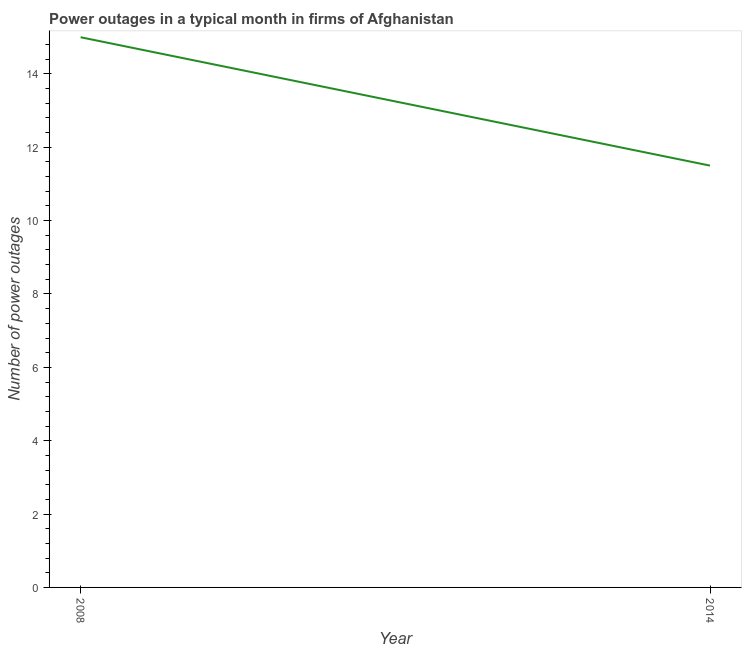What is the number of power outages in 2008?
Ensure brevity in your answer.  15. Across all years, what is the minimum number of power outages?
Give a very brief answer. 11.5. In which year was the number of power outages maximum?
Your answer should be very brief. 2008. In which year was the number of power outages minimum?
Provide a short and direct response. 2014. What is the average number of power outages per year?
Provide a succinct answer. 13.25. What is the median number of power outages?
Ensure brevity in your answer.  13.25. In how many years, is the number of power outages greater than 4.8 ?
Provide a succinct answer. 2. Do a majority of the years between 2014 and 2008 (inclusive) have number of power outages greater than 1.6 ?
Your response must be concise. No. What is the ratio of the number of power outages in 2008 to that in 2014?
Offer a very short reply. 1.3. In how many years, is the number of power outages greater than the average number of power outages taken over all years?
Your answer should be very brief. 1. How many lines are there?
Your answer should be very brief. 1. What is the difference between two consecutive major ticks on the Y-axis?
Make the answer very short. 2. Does the graph contain any zero values?
Keep it short and to the point. No. Does the graph contain grids?
Provide a succinct answer. No. What is the title of the graph?
Give a very brief answer. Power outages in a typical month in firms of Afghanistan. What is the label or title of the Y-axis?
Provide a succinct answer. Number of power outages. What is the Number of power outages in 2008?
Make the answer very short. 15. What is the ratio of the Number of power outages in 2008 to that in 2014?
Provide a short and direct response. 1.3. 